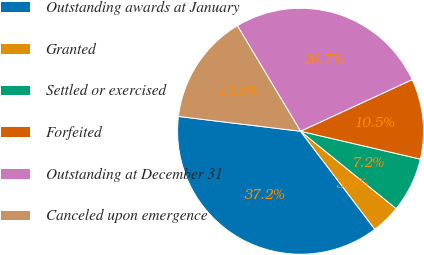Convert chart. <chart><loc_0><loc_0><loc_500><loc_500><pie_chart><fcel>Outstanding awards at January<fcel>Granted<fcel>Settled or exercised<fcel>Forfeited<fcel>Outstanding at December 31<fcel>Canceled upon emergence<nl><fcel>37.24%<fcel>3.85%<fcel>7.19%<fcel>10.53%<fcel>26.69%<fcel>14.49%<nl></chart> 